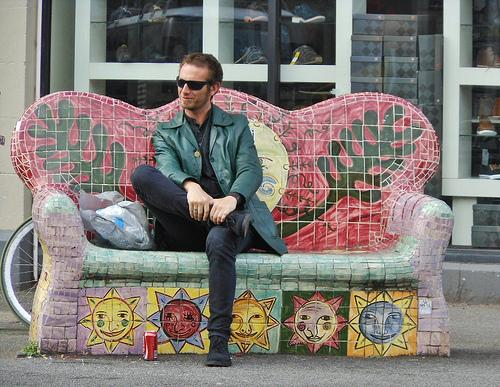Identify the primary focus of the image and provide a brief overview of it. The main focus is a multicolored painted bench with a man sitting on it wearing a green leather jacket, black sunglasses, and jeans, while crossing his legs. Provide a brief description of the man's sitting position on the bench. The man is seated with one leg crossed over the other. What is the man wearing on his face, and what color is it? The man is wearing black sunglasses over his eyes. What is the notable feature about the bench in the image? The bench is painted with various colors and features artistic designs, making it visually appealing. Mention any object found in front of a building in the image and describe it. There are tinted windows in front of a building, with a grey wall surrounding them. What type of jacket is the man wearing, and what color is it? The man is wearing a green leather jacket. Mention an object found near the man sitting on the bench and describe its appearance. A plastic bag is sitting on the sofa beside the man, with an unclear content inside it. What is the color and pattern of the sofa in the image? The sofa has square tiles and comes in a mix of red, blue, and pink art decorations. Describe the color and appearance of the can in the image. The can is red and white, resembling a Coca Cola can, and is found on the ground near the bench. Describe any plant or growth near the bench in the image. There is a patch of weed growing by the corner of the bench. What colors can be seen on the Coca Cola can? Red and white Identify the expression on the sun if it has one. Smiley face What is the man's leg position on the bench? Crossed In front of the man, what beverage might you find? Option 2: Orange Juice What type of art style decorates the sofa? Red blue and pink art Do the windows in front of the building have green curtains? There are windows in the image, but there is no mention of curtains, let alone green ones. What object is partially visible near the bench? Part of a bicycle tire Are the sunglasses on the man's head purple? The man is wearing sunglasses, but they are described as black, not purple. Is the man sitting with both legs straight? There is a man sitting in the image, but he is described as sitting with his leg crossed, not both legs straight. Explain the ground's appearance in the image. Grey ground Is the man wearing a yellow jacket? There is a man wearing a jacket, but the jacket is described as green leather, not yellow. Is the man sitting indoors or outdoors? Outdoors Is there an orange bicycle tire in the image? There is a part of a bicycle tire in the image, but it is not mentioned to be orange in color. How would you describe the man's jacket in terms of material and color? Green leather jacket Write a caption about the bench in the image. What a lovely, colorful painted bench What type of can is sitting on the ground? Coca Cola can Describe the sunglasses on the man's face. Black sunglasses Identify the object on display in the window. Brown shoe Is the Coca-Cola can blue and white? There is a Coca-Cola can present in the image, but it is described as red and white, not blue and white. Are there any plants near the scene? Yes, weed growing by corner of bench Tell me about the man's sitting position. Sitting with leg crossed What is sitting next to the man on the sofa? Plastic bag What type of windows are in front of the building? Tinted windows Is the man wearing any jewelry? Yes, a necklace What color is the painted bench? Multicolored 